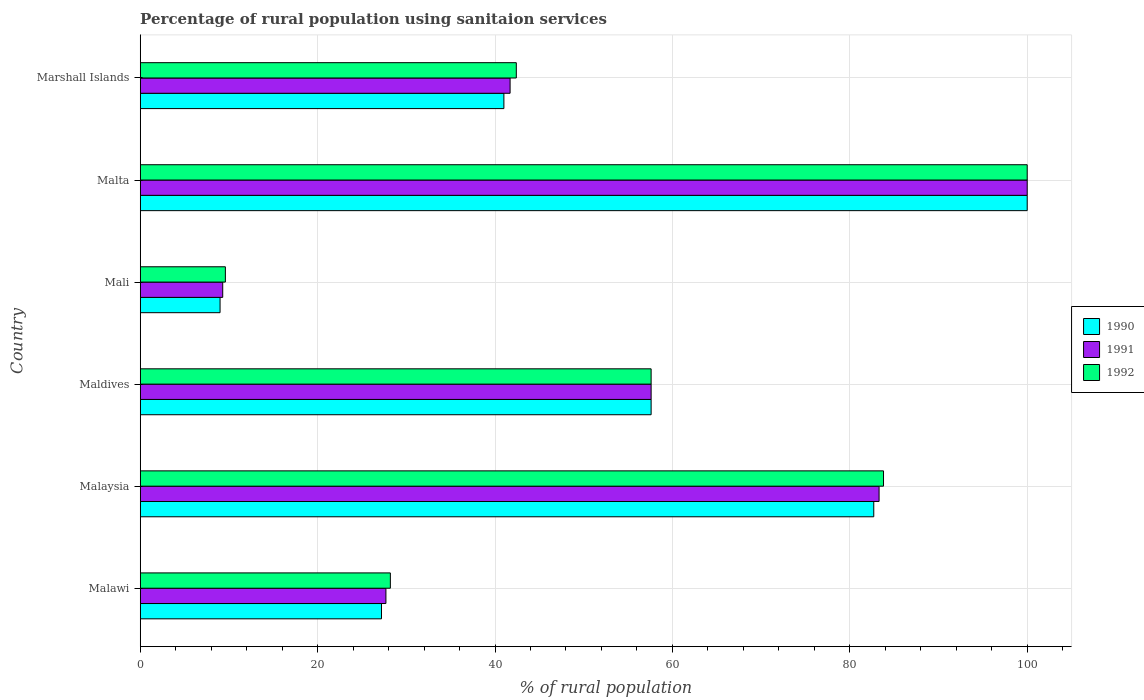How many groups of bars are there?
Your response must be concise. 6. Are the number of bars on each tick of the Y-axis equal?
Your answer should be very brief. Yes. How many bars are there on the 2nd tick from the top?
Give a very brief answer. 3. What is the label of the 2nd group of bars from the top?
Your response must be concise. Malta. What is the percentage of rural population using sanitaion services in 1990 in Malta?
Offer a very short reply. 100. Across all countries, what is the maximum percentage of rural population using sanitaion services in 1990?
Offer a very short reply. 100. Across all countries, what is the minimum percentage of rural population using sanitaion services in 1990?
Your answer should be very brief. 9. In which country was the percentage of rural population using sanitaion services in 1990 maximum?
Ensure brevity in your answer.  Malta. In which country was the percentage of rural population using sanitaion services in 1992 minimum?
Provide a short and direct response. Mali. What is the total percentage of rural population using sanitaion services in 1991 in the graph?
Give a very brief answer. 319.6. What is the difference between the percentage of rural population using sanitaion services in 1991 in Malta and that in Marshall Islands?
Ensure brevity in your answer.  58.3. What is the difference between the percentage of rural population using sanitaion services in 1992 in Malawi and the percentage of rural population using sanitaion services in 1991 in Maldives?
Your answer should be compact. -29.4. What is the average percentage of rural population using sanitaion services in 1990 per country?
Keep it short and to the point. 52.92. In how many countries, is the percentage of rural population using sanitaion services in 1990 greater than 56 %?
Provide a succinct answer. 3. Is the percentage of rural population using sanitaion services in 1990 in Malawi less than that in Mali?
Your answer should be very brief. No. What is the difference between the highest and the second highest percentage of rural population using sanitaion services in 1992?
Your response must be concise. 16.2. What is the difference between the highest and the lowest percentage of rural population using sanitaion services in 1992?
Give a very brief answer. 90.4. In how many countries, is the percentage of rural population using sanitaion services in 1990 greater than the average percentage of rural population using sanitaion services in 1990 taken over all countries?
Provide a succinct answer. 3. Is the sum of the percentage of rural population using sanitaion services in 1991 in Mali and Malta greater than the maximum percentage of rural population using sanitaion services in 1992 across all countries?
Offer a terse response. Yes. What does the 2nd bar from the top in Mali represents?
Provide a short and direct response. 1991. What does the 2nd bar from the bottom in Malawi represents?
Make the answer very short. 1991. Is it the case that in every country, the sum of the percentage of rural population using sanitaion services in 1990 and percentage of rural population using sanitaion services in 1991 is greater than the percentage of rural population using sanitaion services in 1992?
Ensure brevity in your answer.  Yes. How many bars are there?
Keep it short and to the point. 18. How many countries are there in the graph?
Give a very brief answer. 6. What is the difference between two consecutive major ticks on the X-axis?
Offer a terse response. 20. How many legend labels are there?
Offer a terse response. 3. How are the legend labels stacked?
Your response must be concise. Vertical. What is the title of the graph?
Ensure brevity in your answer.  Percentage of rural population using sanitaion services. Does "1986" appear as one of the legend labels in the graph?
Ensure brevity in your answer.  No. What is the label or title of the X-axis?
Keep it short and to the point. % of rural population. What is the label or title of the Y-axis?
Provide a succinct answer. Country. What is the % of rural population of 1990 in Malawi?
Offer a terse response. 27.2. What is the % of rural population of 1991 in Malawi?
Your answer should be compact. 27.7. What is the % of rural population in 1992 in Malawi?
Your answer should be very brief. 28.2. What is the % of rural population of 1990 in Malaysia?
Provide a succinct answer. 82.7. What is the % of rural population of 1991 in Malaysia?
Make the answer very short. 83.3. What is the % of rural population in 1992 in Malaysia?
Your response must be concise. 83.8. What is the % of rural population of 1990 in Maldives?
Give a very brief answer. 57.6. What is the % of rural population of 1991 in Maldives?
Provide a short and direct response. 57.6. What is the % of rural population in 1992 in Maldives?
Offer a terse response. 57.6. What is the % of rural population in 1991 in Mali?
Ensure brevity in your answer.  9.3. What is the % of rural population of 1990 in Marshall Islands?
Your answer should be compact. 41. What is the % of rural population in 1991 in Marshall Islands?
Offer a very short reply. 41.7. What is the % of rural population of 1992 in Marshall Islands?
Make the answer very short. 42.4. Across all countries, what is the maximum % of rural population of 1992?
Offer a terse response. 100. What is the total % of rural population of 1990 in the graph?
Your answer should be very brief. 317.5. What is the total % of rural population of 1991 in the graph?
Your response must be concise. 319.6. What is the total % of rural population of 1992 in the graph?
Ensure brevity in your answer.  321.6. What is the difference between the % of rural population of 1990 in Malawi and that in Malaysia?
Your answer should be very brief. -55.5. What is the difference between the % of rural population in 1991 in Malawi and that in Malaysia?
Make the answer very short. -55.6. What is the difference between the % of rural population in 1992 in Malawi and that in Malaysia?
Provide a succinct answer. -55.6. What is the difference between the % of rural population in 1990 in Malawi and that in Maldives?
Make the answer very short. -30.4. What is the difference between the % of rural population in 1991 in Malawi and that in Maldives?
Keep it short and to the point. -29.9. What is the difference between the % of rural population of 1992 in Malawi and that in Maldives?
Ensure brevity in your answer.  -29.4. What is the difference between the % of rural population of 1990 in Malawi and that in Mali?
Your answer should be compact. 18.2. What is the difference between the % of rural population in 1991 in Malawi and that in Mali?
Provide a short and direct response. 18.4. What is the difference between the % of rural population in 1992 in Malawi and that in Mali?
Your response must be concise. 18.6. What is the difference between the % of rural population of 1990 in Malawi and that in Malta?
Provide a short and direct response. -72.8. What is the difference between the % of rural population of 1991 in Malawi and that in Malta?
Your answer should be very brief. -72.3. What is the difference between the % of rural population of 1992 in Malawi and that in Malta?
Your answer should be compact. -71.8. What is the difference between the % of rural population of 1990 in Malaysia and that in Maldives?
Provide a succinct answer. 25.1. What is the difference between the % of rural population in 1991 in Malaysia and that in Maldives?
Offer a very short reply. 25.7. What is the difference between the % of rural population of 1992 in Malaysia and that in Maldives?
Offer a very short reply. 26.2. What is the difference between the % of rural population of 1990 in Malaysia and that in Mali?
Ensure brevity in your answer.  73.7. What is the difference between the % of rural population of 1991 in Malaysia and that in Mali?
Ensure brevity in your answer.  74. What is the difference between the % of rural population of 1992 in Malaysia and that in Mali?
Offer a very short reply. 74.2. What is the difference between the % of rural population in 1990 in Malaysia and that in Malta?
Your answer should be compact. -17.3. What is the difference between the % of rural population in 1991 in Malaysia and that in Malta?
Ensure brevity in your answer.  -16.7. What is the difference between the % of rural population in 1992 in Malaysia and that in Malta?
Offer a very short reply. -16.2. What is the difference between the % of rural population of 1990 in Malaysia and that in Marshall Islands?
Keep it short and to the point. 41.7. What is the difference between the % of rural population of 1991 in Malaysia and that in Marshall Islands?
Ensure brevity in your answer.  41.6. What is the difference between the % of rural population in 1992 in Malaysia and that in Marshall Islands?
Give a very brief answer. 41.4. What is the difference between the % of rural population of 1990 in Maldives and that in Mali?
Ensure brevity in your answer.  48.6. What is the difference between the % of rural population of 1991 in Maldives and that in Mali?
Provide a succinct answer. 48.3. What is the difference between the % of rural population in 1992 in Maldives and that in Mali?
Provide a succinct answer. 48. What is the difference between the % of rural population in 1990 in Maldives and that in Malta?
Your response must be concise. -42.4. What is the difference between the % of rural population of 1991 in Maldives and that in Malta?
Offer a very short reply. -42.4. What is the difference between the % of rural population in 1992 in Maldives and that in Malta?
Make the answer very short. -42.4. What is the difference between the % of rural population in 1991 in Maldives and that in Marshall Islands?
Provide a short and direct response. 15.9. What is the difference between the % of rural population in 1990 in Mali and that in Malta?
Offer a terse response. -91. What is the difference between the % of rural population in 1991 in Mali and that in Malta?
Offer a very short reply. -90.7. What is the difference between the % of rural population in 1992 in Mali and that in Malta?
Your response must be concise. -90.4. What is the difference between the % of rural population in 1990 in Mali and that in Marshall Islands?
Ensure brevity in your answer.  -32. What is the difference between the % of rural population in 1991 in Mali and that in Marshall Islands?
Provide a short and direct response. -32.4. What is the difference between the % of rural population in 1992 in Mali and that in Marshall Islands?
Your response must be concise. -32.8. What is the difference between the % of rural population in 1991 in Malta and that in Marshall Islands?
Offer a very short reply. 58.3. What is the difference between the % of rural population of 1992 in Malta and that in Marshall Islands?
Offer a terse response. 57.6. What is the difference between the % of rural population in 1990 in Malawi and the % of rural population in 1991 in Malaysia?
Offer a very short reply. -56.1. What is the difference between the % of rural population in 1990 in Malawi and the % of rural population in 1992 in Malaysia?
Your response must be concise. -56.6. What is the difference between the % of rural population in 1991 in Malawi and the % of rural population in 1992 in Malaysia?
Provide a short and direct response. -56.1. What is the difference between the % of rural population in 1990 in Malawi and the % of rural population in 1991 in Maldives?
Ensure brevity in your answer.  -30.4. What is the difference between the % of rural population in 1990 in Malawi and the % of rural population in 1992 in Maldives?
Your answer should be compact. -30.4. What is the difference between the % of rural population of 1991 in Malawi and the % of rural population of 1992 in Maldives?
Provide a short and direct response. -29.9. What is the difference between the % of rural population of 1990 in Malawi and the % of rural population of 1991 in Mali?
Keep it short and to the point. 17.9. What is the difference between the % of rural population in 1990 in Malawi and the % of rural population in 1992 in Mali?
Your response must be concise. 17.6. What is the difference between the % of rural population in 1990 in Malawi and the % of rural population in 1991 in Malta?
Offer a terse response. -72.8. What is the difference between the % of rural population in 1990 in Malawi and the % of rural population in 1992 in Malta?
Provide a short and direct response. -72.8. What is the difference between the % of rural population of 1991 in Malawi and the % of rural population of 1992 in Malta?
Provide a succinct answer. -72.3. What is the difference between the % of rural population of 1990 in Malawi and the % of rural population of 1992 in Marshall Islands?
Offer a terse response. -15.2. What is the difference between the % of rural population of 1991 in Malawi and the % of rural population of 1992 in Marshall Islands?
Offer a terse response. -14.7. What is the difference between the % of rural population in 1990 in Malaysia and the % of rural population in 1991 in Maldives?
Ensure brevity in your answer.  25.1. What is the difference between the % of rural population in 1990 in Malaysia and the % of rural population in 1992 in Maldives?
Ensure brevity in your answer.  25.1. What is the difference between the % of rural population in 1991 in Malaysia and the % of rural population in 1992 in Maldives?
Keep it short and to the point. 25.7. What is the difference between the % of rural population in 1990 in Malaysia and the % of rural population in 1991 in Mali?
Your response must be concise. 73.4. What is the difference between the % of rural population of 1990 in Malaysia and the % of rural population of 1992 in Mali?
Offer a very short reply. 73.1. What is the difference between the % of rural population in 1991 in Malaysia and the % of rural population in 1992 in Mali?
Your response must be concise. 73.7. What is the difference between the % of rural population in 1990 in Malaysia and the % of rural population in 1991 in Malta?
Give a very brief answer. -17.3. What is the difference between the % of rural population of 1990 in Malaysia and the % of rural population of 1992 in Malta?
Provide a succinct answer. -17.3. What is the difference between the % of rural population in 1991 in Malaysia and the % of rural population in 1992 in Malta?
Keep it short and to the point. -16.7. What is the difference between the % of rural population in 1990 in Malaysia and the % of rural population in 1992 in Marshall Islands?
Provide a short and direct response. 40.3. What is the difference between the % of rural population in 1991 in Malaysia and the % of rural population in 1992 in Marshall Islands?
Ensure brevity in your answer.  40.9. What is the difference between the % of rural population in 1990 in Maldives and the % of rural population in 1991 in Mali?
Your answer should be very brief. 48.3. What is the difference between the % of rural population of 1991 in Maldives and the % of rural population of 1992 in Mali?
Ensure brevity in your answer.  48. What is the difference between the % of rural population of 1990 in Maldives and the % of rural population of 1991 in Malta?
Your response must be concise. -42.4. What is the difference between the % of rural population in 1990 in Maldives and the % of rural population in 1992 in Malta?
Keep it short and to the point. -42.4. What is the difference between the % of rural population in 1991 in Maldives and the % of rural population in 1992 in Malta?
Provide a succinct answer. -42.4. What is the difference between the % of rural population in 1990 in Maldives and the % of rural population in 1991 in Marshall Islands?
Your answer should be compact. 15.9. What is the difference between the % of rural population of 1990 in Maldives and the % of rural population of 1992 in Marshall Islands?
Your response must be concise. 15.2. What is the difference between the % of rural population in 1990 in Mali and the % of rural population in 1991 in Malta?
Ensure brevity in your answer.  -91. What is the difference between the % of rural population of 1990 in Mali and the % of rural population of 1992 in Malta?
Your answer should be compact. -91. What is the difference between the % of rural population in 1991 in Mali and the % of rural population in 1992 in Malta?
Offer a terse response. -90.7. What is the difference between the % of rural population of 1990 in Mali and the % of rural population of 1991 in Marshall Islands?
Ensure brevity in your answer.  -32.7. What is the difference between the % of rural population in 1990 in Mali and the % of rural population in 1992 in Marshall Islands?
Make the answer very short. -33.4. What is the difference between the % of rural population of 1991 in Mali and the % of rural population of 1992 in Marshall Islands?
Offer a very short reply. -33.1. What is the difference between the % of rural population in 1990 in Malta and the % of rural population in 1991 in Marshall Islands?
Offer a terse response. 58.3. What is the difference between the % of rural population of 1990 in Malta and the % of rural population of 1992 in Marshall Islands?
Keep it short and to the point. 57.6. What is the difference between the % of rural population of 1991 in Malta and the % of rural population of 1992 in Marshall Islands?
Keep it short and to the point. 57.6. What is the average % of rural population of 1990 per country?
Your answer should be very brief. 52.92. What is the average % of rural population in 1991 per country?
Offer a terse response. 53.27. What is the average % of rural population in 1992 per country?
Provide a short and direct response. 53.6. What is the difference between the % of rural population of 1990 and % of rural population of 1992 in Maldives?
Keep it short and to the point. 0. What is the difference between the % of rural population in 1990 and % of rural population in 1992 in Mali?
Your response must be concise. -0.6. What is the difference between the % of rural population in 1991 and % of rural population in 1992 in Mali?
Provide a short and direct response. -0.3. What is the difference between the % of rural population of 1990 and % of rural population of 1991 in Malta?
Ensure brevity in your answer.  0. What is the difference between the % of rural population in 1991 and % of rural population in 1992 in Malta?
Give a very brief answer. 0. What is the difference between the % of rural population of 1990 and % of rural population of 1992 in Marshall Islands?
Your answer should be compact. -1.4. What is the difference between the % of rural population of 1991 and % of rural population of 1992 in Marshall Islands?
Your answer should be compact. -0.7. What is the ratio of the % of rural population in 1990 in Malawi to that in Malaysia?
Provide a succinct answer. 0.33. What is the ratio of the % of rural population in 1991 in Malawi to that in Malaysia?
Keep it short and to the point. 0.33. What is the ratio of the % of rural population of 1992 in Malawi to that in Malaysia?
Your answer should be compact. 0.34. What is the ratio of the % of rural population in 1990 in Malawi to that in Maldives?
Provide a short and direct response. 0.47. What is the ratio of the % of rural population in 1991 in Malawi to that in Maldives?
Provide a succinct answer. 0.48. What is the ratio of the % of rural population of 1992 in Malawi to that in Maldives?
Provide a succinct answer. 0.49. What is the ratio of the % of rural population of 1990 in Malawi to that in Mali?
Your response must be concise. 3.02. What is the ratio of the % of rural population in 1991 in Malawi to that in Mali?
Ensure brevity in your answer.  2.98. What is the ratio of the % of rural population in 1992 in Malawi to that in Mali?
Offer a very short reply. 2.94. What is the ratio of the % of rural population in 1990 in Malawi to that in Malta?
Keep it short and to the point. 0.27. What is the ratio of the % of rural population of 1991 in Malawi to that in Malta?
Provide a succinct answer. 0.28. What is the ratio of the % of rural population in 1992 in Malawi to that in Malta?
Your answer should be very brief. 0.28. What is the ratio of the % of rural population of 1990 in Malawi to that in Marshall Islands?
Give a very brief answer. 0.66. What is the ratio of the % of rural population in 1991 in Malawi to that in Marshall Islands?
Your response must be concise. 0.66. What is the ratio of the % of rural population of 1992 in Malawi to that in Marshall Islands?
Provide a succinct answer. 0.67. What is the ratio of the % of rural population in 1990 in Malaysia to that in Maldives?
Your answer should be very brief. 1.44. What is the ratio of the % of rural population of 1991 in Malaysia to that in Maldives?
Your response must be concise. 1.45. What is the ratio of the % of rural population in 1992 in Malaysia to that in Maldives?
Give a very brief answer. 1.45. What is the ratio of the % of rural population of 1990 in Malaysia to that in Mali?
Your answer should be very brief. 9.19. What is the ratio of the % of rural population in 1991 in Malaysia to that in Mali?
Give a very brief answer. 8.96. What is the ratio of the % of rural population of 1992 in Malaysia to that in Mali?
Give a very brief answer. 8.73. What is the ratio of the % of rural population of 1990 in Malaysia to that in Malta?
Provide a short and direct response. 0.83. What is the ratio of the % of rural population in 1991 in Malaysia to that in Malta?
Make the answer very short. 0.83. What is the ratio of the % of rural population of 1992 in Malaysia to that in Malta?
Keep it short and to the point. 0.84. What is the ratio of the % of rural population in 1990 in Malaysia to that in Marshall Islands?
Your answer should be compact. 2.02. What is the ratio of the % of rural population of 1991 in Malaysia to that in Marshall Islands?
Give a very brief answer. 2. What is the ratio of the % of rural population of 1992 in Malaysia to that in Marshall Islands?
Give a very brief answer. 1.98. What is the ratio of the % of rural population in 1990 in Maldives to that in Mali?
Your response must be concise. 6.4. What is the ratio of the % of rural population of 1991 in Maldives to that in Mali?
Provide a short and direct response. 6.19. What is the ratio of the % of rural population in 1990 in Maldives to that in Malta?
Your answer should be very brief. 0.58. What is the ratio of the % of rural population in 1991 in Maldives to that in Malta?
Give a very brief answer. 0.58. What is the ratio of the % of rural population of 1992 in Maldives to that in Malta?
Give a very brief answer. 0.58. What is the ratio of the % of rural population in 1990 in Maldives to that in Marshall Islands?
Offer a terse response. 1.4. What is the ratio of the % of rural population of 1991 in Maldives to that in Marshall Islands?
Offer a very short reply. 1.38. What is the ratio of the % of rural population of 1992 in Maldives to that in Marshall Islands?
Give a very brief answer. 1.36. What is the ratio of the % of rural population in 1990 in Mali to that in Malta?
Keep it short and to the point. 0.09. What is the ratio of the % of rural population in 1991 in Mali to that in Malta?
Keep it short and to the point. 0.09. What is the ratio of the % of rural population in 1992 in Mali to that in Malta?
Your answer should be compact. 0.1. What is the ratio of the % of rural population of 1990 in Mali to that in Marshall Islands?
Provide a succinct answer. 0.22. What is the ratio of the % of rural population of 1991 in Mali to that in Marshall Islands?
Make the answer very short. 0.22. What is the ratio of the % of rural population of 1992 in Mali to that in Marshall Islands?
Your response must be concise. 0.23. What is the ratio of the % of rural population in 1990 in Malta to that in Marshall Islands?
Your response must be concise. 2.44. What is the ratio of the % of rural population of 1991 in Malta to that in Marshall Islands?
Give a very brief answer. 2.4. What is the ratio of the % of rural population in 1992 in Malta to that in Marshall Islands?
Keep it short and to the point. 2.36. What is the difference between the highest and the lowest % of rural population in 1990?
Your answer should be very brief. 91. What is the difference between the highest and the lowest % of rural population in 1991?
Provide a short and direct response. 90.7. What is the difference between the highest and the lowest % of rural population of 1992?
Your answer should be compact. 90.4. 